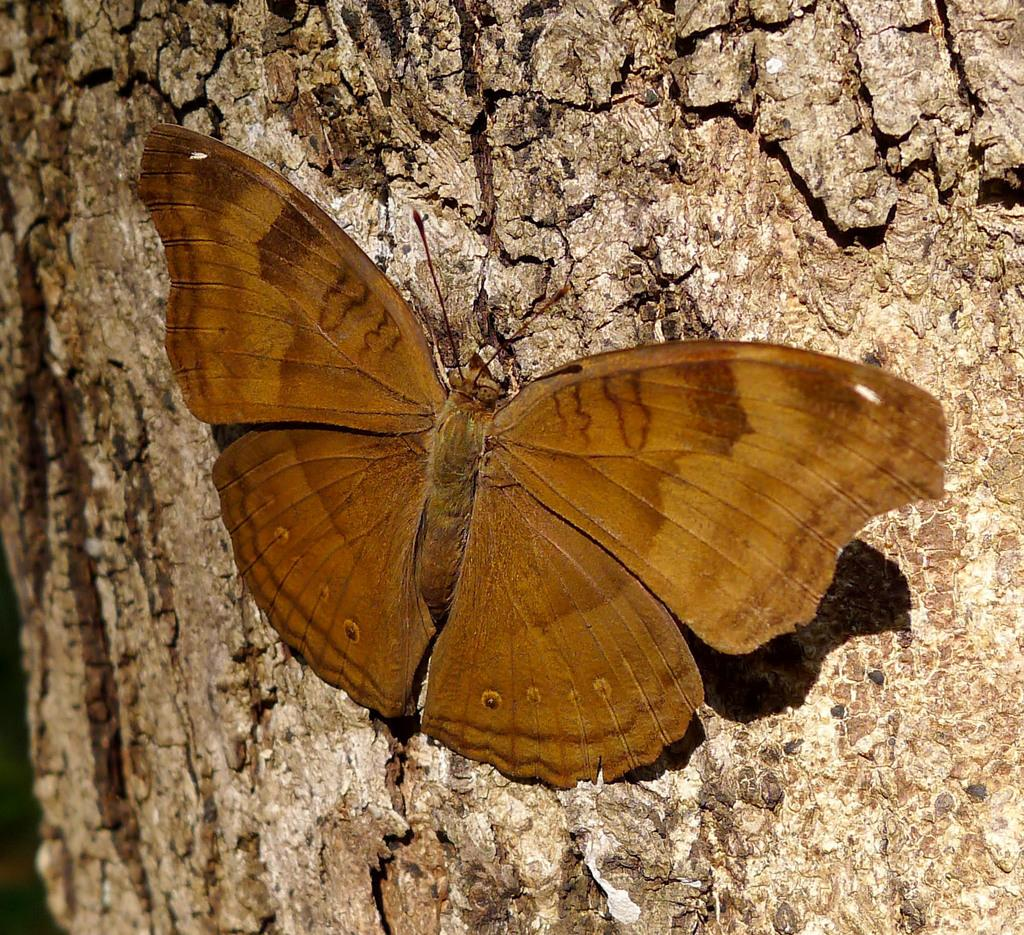What type of insect is present in the image? There is a butterfly in the image. What color is the butterfly? The butterfly is brown in color. What type of hook is used to catch the butterfly in the image? There is no hook present in the image, and the butterfly is not being caught. 